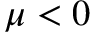Convert formula to latex. <formula><loc_0><loc_0><loc_500><loc_500>\mu < 0</formula> 